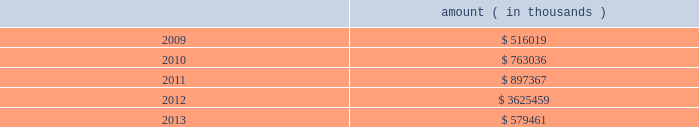Entergy corporation and subsidiaries notes to financial statements ( a ) consists of pollution control revenue bonds and environmental revenue bonds .
( b ) the bonds are secured by a series of collateral first mortgage bonds .
( c ) in december 2005 , entergy corporation sold 10 million equity units with a stated amount of $ 50 each .
An equity unit consisted of ( 1 ) a note , initially due february 2011 and initially bearing interest at an annual rate of 5.75% ( 5.75 % ) , and ( 2 ) a purchase contract that obligated the holder of the equity unit to purchase for $ 50 between 0.5705 and 0.7074 shares of entergy corporation common stock on or before february 17 , 2009 .
Entergy paid the holders quarterly contract adjustment payments of 1.875% ( 1.875 % ) per year on the stated amount of $ 50 per equity unit .
Under the terms of the purchase contracts , entergy attempted to remarket the notes in february 2009 but was unsuccessful , the note holders put the notes to entergy , entergy retired the notes , and entergy issued 6598000 shares of common stock in the settlement of the purchase contracts .
( d ) pursuant to the nuclear waste policy act of 1982 , entergy's nuclear owner/licensee subsidiaries have contracts with the doe for spent nuclear fuel disposal service .
The contracts include a one-time fee for generation prior to april 7 , 1983 .
Entergy arkansas is the only entergy company that generated electric power with nuclear fuel prior to that date and includes the one-time fee , plus accrued interest , in long-term ( e ) the fair value excludes lease obligations , long-term doe obligations , and the note payable to nypa , and includes debt due within one year .
It is determined using bid prices reported by dealer markets and by nationally recognized investment banking firms .
( f ) entergy gulf states louisiana remains primarily liable for all of the long-term debt issued by entergy gulf states , inc .
That was outstanding on december 31 , 2008 and 2007 .
Under a debt assumption agreement with entergy gulf states louisiana , entergy texas assumed approximately 46% ( 46 % ) of this long-term debt .
The annual long-term debt maturities ( excluding lease obligations ) for debt outstanding as of december 31 , 2008 , for the next five years are as follows : amount ( in thousands ) .
In november 2000 , entergy's non-utility nuclear business purchased the fitzpatrick and indian point 3 power plants in a seller-financed transaction .
Entergy issued notes to nypa with seven annual installments of approximately $ 108 million commencing one year from the date of the closing , and eight annual installments of $ 20 million commencing eight years from the date of the closing .
These notes do not have a stated interest rate , but have an implicit interest rate of 4.8% ( 4.8 % ) .
In accordance with the purchase agreement with nypa , the purchase of indian point 2 in 2001 resulted in entergy's non-utility nuclear business becoming liable to nypa for an additional $ 10 million per year for 10 years , beginning in september 2003 .
This liability was recorded upon the purchase of indian point 2 in september 2001 , and is included in the note payable to nypa balance above .
In july 2003 , a payment of $ 102 million was made prior to maturity on the note payable to nypa .
Under a provision in a letter of credit supporting these notes , if certain of the utility operating companies or system energy were to default on other indebtedness , entergy could be required to post collateral to support the letter of credit .
Covenants in the entergy corporation notes require it to maintain a consolidated debt ratio of 65% ( 65 % ) or less of its total capitalization .
If entergy's debt ratio exceeds this limit , or if entergy or certain of the utility operating companies default on other indebtedness or are in bankruptcy or insolvency proceedings , an acceleration of the notes' maturity dates may occur .
Entergy gulf states louisiana , entergy louisiana , entergy mississippi , entergy texas , and system energy have received ferc long-term financing orders authorizing long-term securities issuances .
Entergy arkansas has .
2012 debt maturities is what percent higher than the next highest year ( 2011 ) ? 
Computations: ((3625459 - 897367) / 897367)
Answer: 3.04011. 